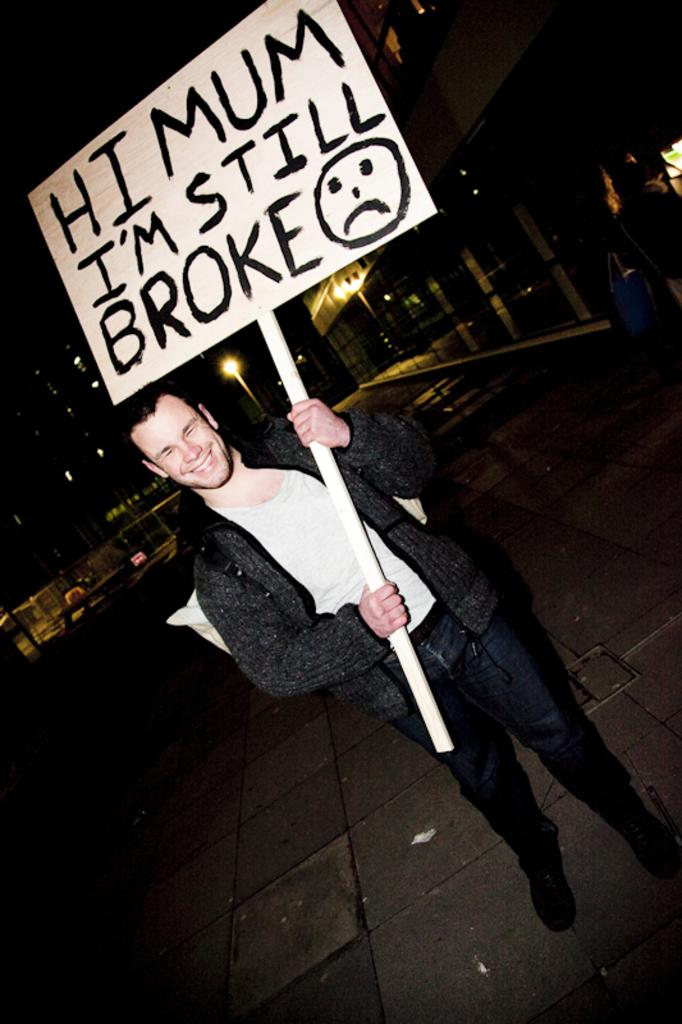What is the main subject of the image? There is a person standing in the center of the image. What is the person holding in the image? The person is holding a board. What can be seen in the distance behind the person? There are buildings in the background of the image. What surface is visible at the bottom of the image? There is a walkway at the bottom of the image. Is the existence of snow confirmed in the image? There is no mention of snow in the image, so we cannot confirm its existence. 